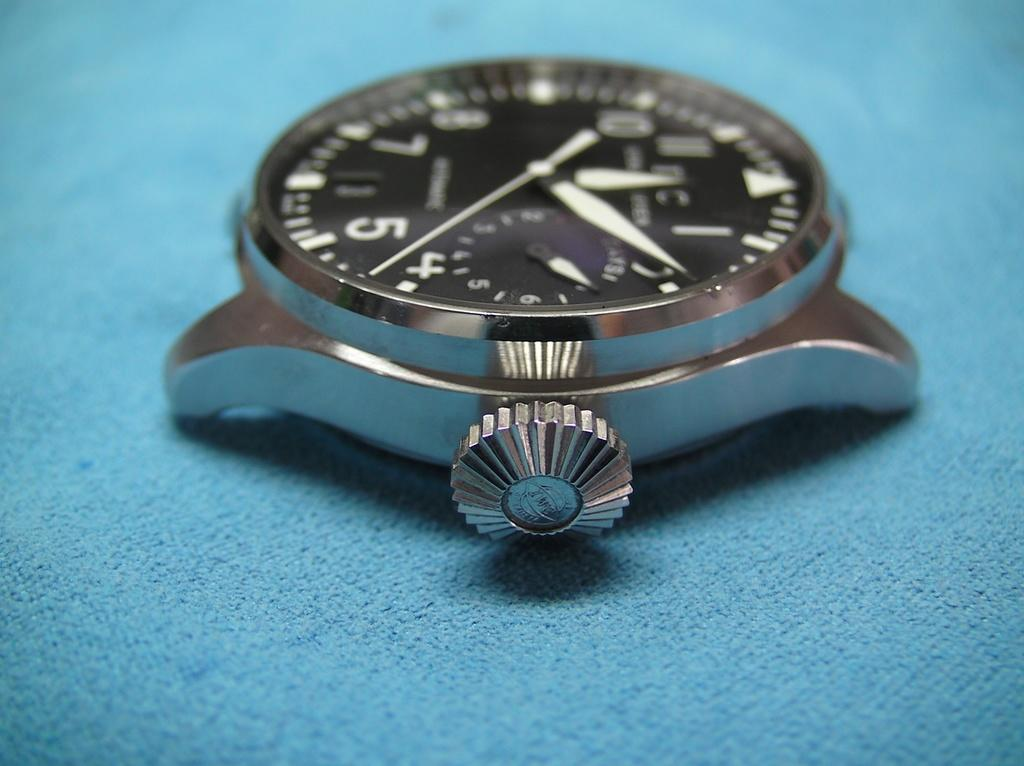<image>
Share a concise interpretation of the image provided. Face of a watch that has one of the hands between the 4 and 5. 